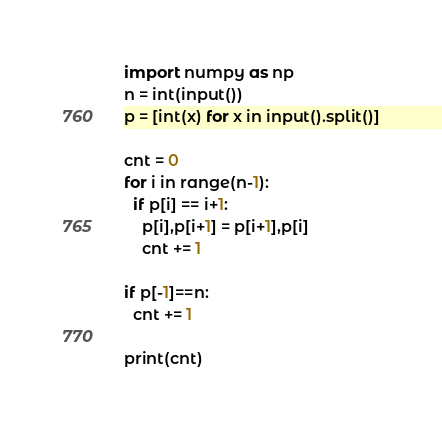Convert code to text. <code><loc_0><loc_0><loc_500><loc_500><_Python_>import numpy as np
n = int(input())
p = [int(x) for x in input().split()]

cnt = 0
for i in range(n-1):
  if p[i] == i+1:
    p[i],p[i+1] = p[i+1],p[i]
    cnt += 1

if p[-1]==n:
  cnt += 1
  
print(cnt)

</code> 